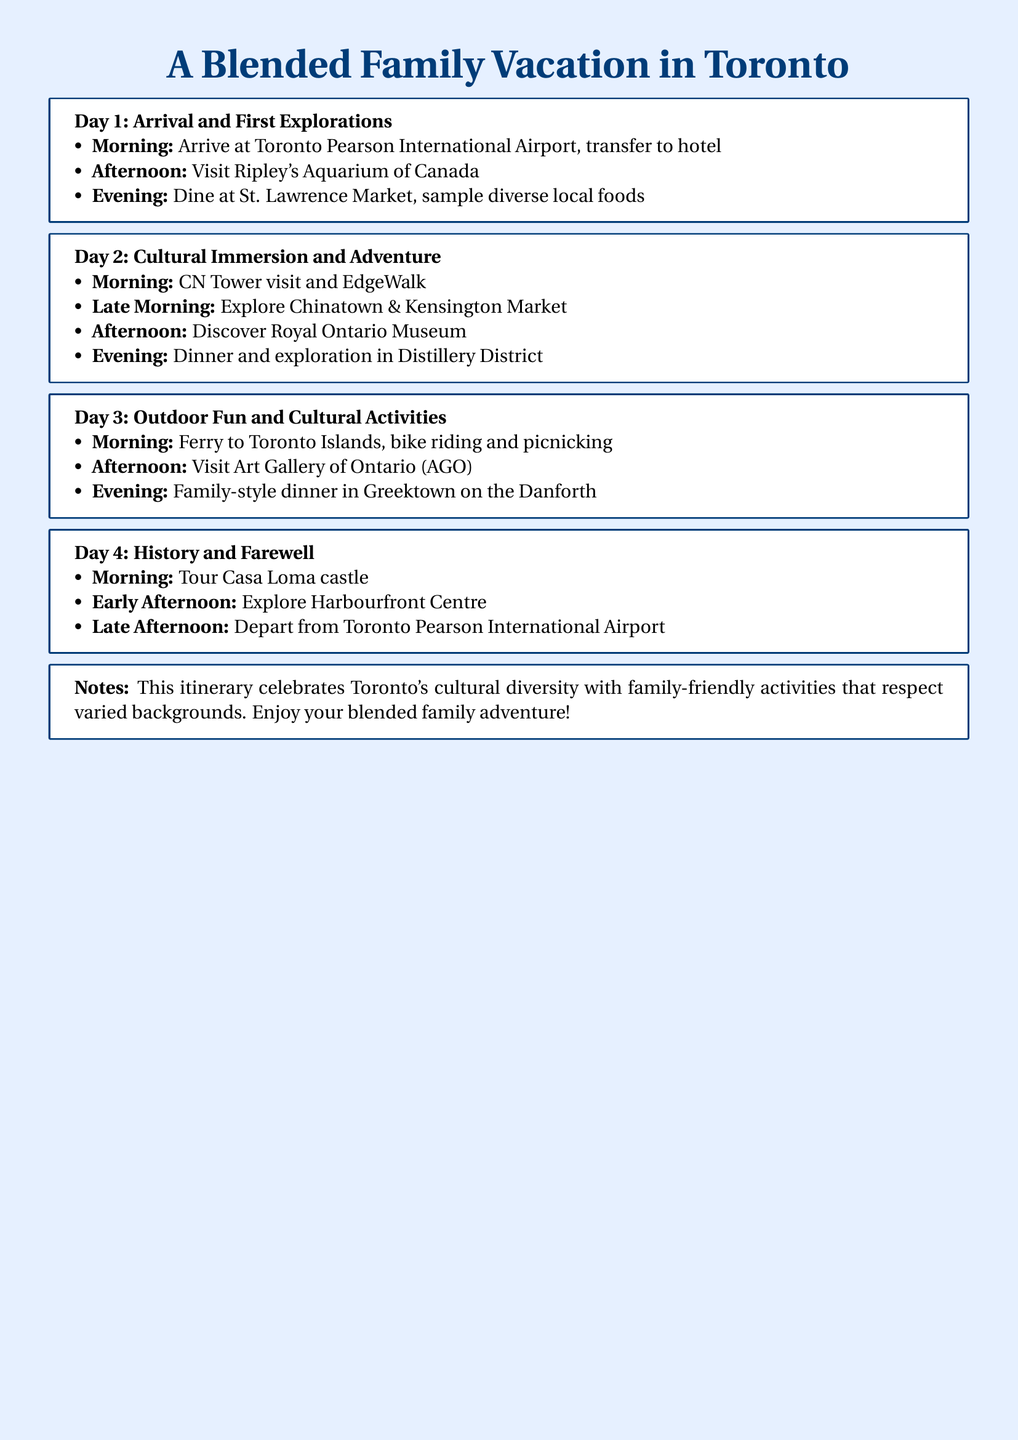What is the title of the itinerary? The title of the itinerary highlights the destination and theme of the trip, which is "A Blended Family Vacation in Toronto."
Answer: A Blended Family Vacation in Toronto How many days does the itinerary cover? The itinerary is organized into sections for each day, totaling four days.
Answer: 4 days What is the first activity listed for Day 1? The first activity listed for Day 1 is arriving at a specific location, which is Toronto Pearson International Airport.
Answer: Arrive at Toronto Pearson International Airport Which market does the itinerary suggest for diverse local foods? The itinerary mentions St. Lawrence Market as a spot to sample diverse local foods.
Answer: St. Lawrence Market Where do families go for a picnic on Day 3? The itinerary specifies that families can picnic after taking a ferry to a certain location, which is Toronto Islands.
Answer: Toronto Islands What type of dinner experience is suggested for Day 3 in Greektown? The itinerary recommends a particular dining style for that evening, which is a family-style dinner.
Answer: Family-style dinner What cultural landmark is visited on Day 2? The itinerary lists the Royal Ontario Museum as a cultural landmark to visit on Day 2.
Answer: Royal Ontario Museum What type of cuisine is highlighted on Day 3? The itinerary indicates that the dinner on Day 3 focuses on a specific cultural cuisine from a location, which is Greektown.
Answer: Greektown cuisine 